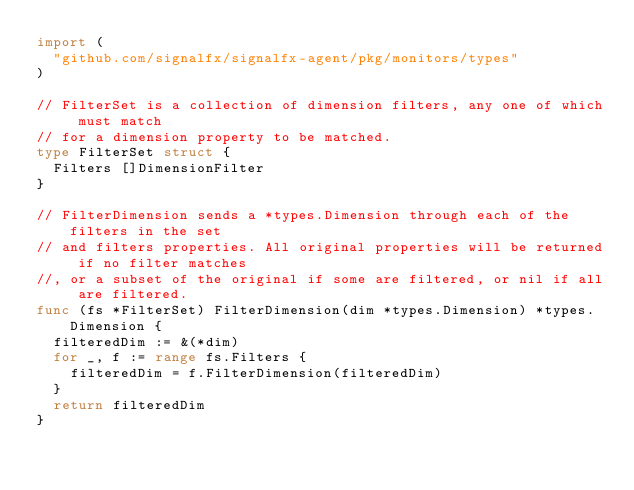<code> <loc_0><loc_0><loc_500><loc_500><_Go_>import (
	"github.com/signalfx/signalfx-agent/pkg/monitors/types"
)

// FilterSet is a collection of dimension filters, any one of which must match
// for a dimension property to be matched.
type FilterSet struct {
	Filters []DimensionFilter
}

// FilterDimension sends a *types.Dimension through each of the filters in the set
// and filters properties. All original properties will be returned if no filter matches
//, or a subset of the original if some are filtered, or nil if all are filtered.
func (fs *FilterSet) FilterDimension(dim *types.Dimension) *types.Dimension {
	filteredDim := &(*dim)
	for _, f := range fs.Filters {
		filteredDim = f.FilterDimension(filteredDim)
	}
	return filteredDim
}
</code> 